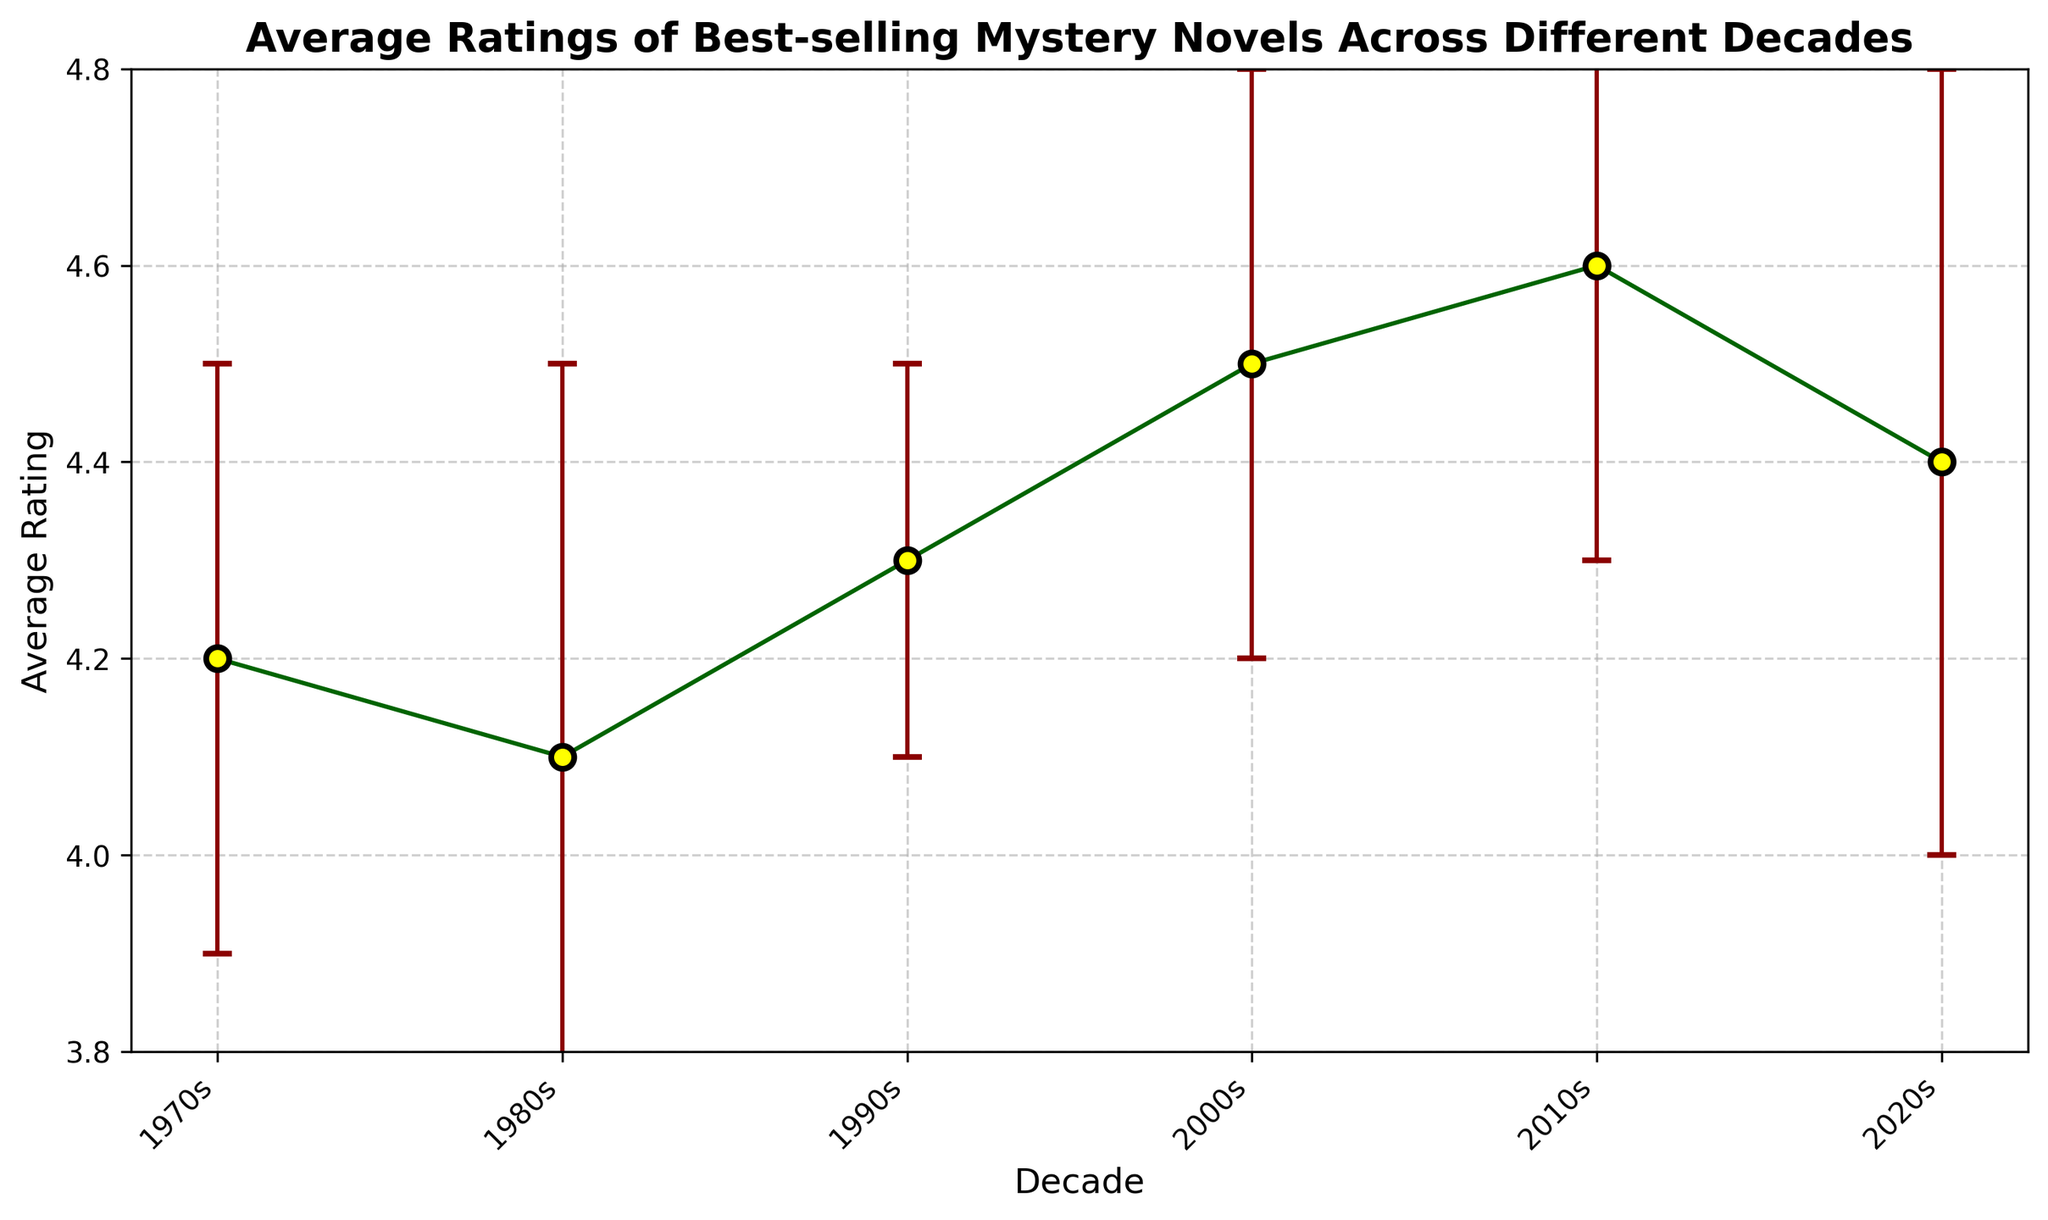What's the highest average rating recorded in the figure? The highest average rating can be identified by looking at the peak of the data points. Here, the 2010s have the highest average rating of 4.6.
Answer: 4.6 Which decade had the lowest average rating? By comparing the data points, the lowest average rating is seen in the 1980s, which has an average rating of 4.1.
Answer: 1980s What is the difference in average rating between the 2000s and the 2020s? The average rating for the 2000s is 4.5 and for the 2020s is 4.4. The difference between them is 4.5 - 4.4 = 0.1.
Answer: 0.1 Between which two consecutive decades did the average rating increase the most? By examining the increase between each decade, the largest increase is from the 1980s to the 1990s (0.2 units).
Answer: 1980s to 1990s What is the range of average ratings across all decades in the figure? The range is found by subtracting the lowest average rating (4.1 in the 1980s) from the highest average rating (4.6 in the 2010s). The range is 4.6 - 4.1 = 0.5.
Answer: 0.5 Which decade has the smallest error bars? The error bars represent the standard deviation. The smallest error bars appear in the 1990s with a standard deviation of 0.2.
Answer: 1990s Are there any decades where the error bars overlap with each other? By visually inspecting the error bars, the error bars for the 2020s overlap with those for the 2000s and the 2010s.
Answer: Yes By how much did the average rating increase from the 1970s to the 2010s? The average rating in the 1970s is 4.2 and in the 2010s is 4.6. The increase is calculated as 4.6 - 4.2 = 0.4.
Answer: 0.4 What is the average of the average ratings across all decades? Sum up all the average ratings (4.2 + 4.1 + 4.3 + 4.5 + 4.6 + 4.4 = 26.1) and divide by the number of decades (6). The average is 26.1 / 6 ≈ 4.35.
Answer: 4.35 Is the average rating of the 2020s higher or lower than that of the 2010s? By how much? The average rating of the 2020s is 4.4, while that of the 2010s is 4.6. Comparing the two, the 2020s' rating is lower by 4.6 - 4.4 = 0.2.
Answer: Lower by 0.2 